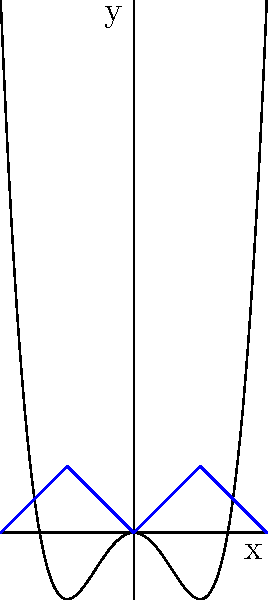The image shows a complex fractal-like pattern. What mathematical principle is primarily responsible for generating the self-similar structures in this pattern, and how does it relate to the concept of iteration? To understand the mathematical principle behind this fractal-like pattern, let's break it down step-by-step:

1. Observe the overall shape: The pattern consists of a central curve with smaller, similar curves branching off on either side.

2. Identify the base function: The main curve appears to be a quartic function, likely of the form $f(x) = x^4 - 2x^2$.

3. Notice the self-similarity: The blue V-shaped sections on either side of the central curve resemble smaller versions of the main curve.

4. Understand iteration: Iteration involves repeatedly applying a function or process to an initial value or shape.

5. Recognize the iterative process: The pattern is generated by repeatedly applying a transformation to the base curve, creating smaller copies at different scales and orientations.

6. Relate to fractals: This process of creating self-similar structures at different scales is a key characteristic of fractals.

7. Identify the principle: The mathematical principle responsible for this pattern is the iterative application of a function or transformation, which is fundamental to fractal geometry.

8. Consider the Mandelbrot set: While this is not the Mandelbrot set, it shares the principle of using iteration to generate complex, self-similar patterns.

The iteration principle allows for the creation of intricate, infinitely detailed structures from simple mathematical rules, resulting in the visually striking and complex patterns characteristic of fractals.
Answer: Iteration 